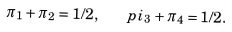<formula> <loc_0><loc_0><loc_500><loc_500>\pi _ { 1 } + \pi _ { 2 } = 1 / 2 , \quad p i _ { 3 } + \pi _ { 4 } = 1 / 2 .</formula> 